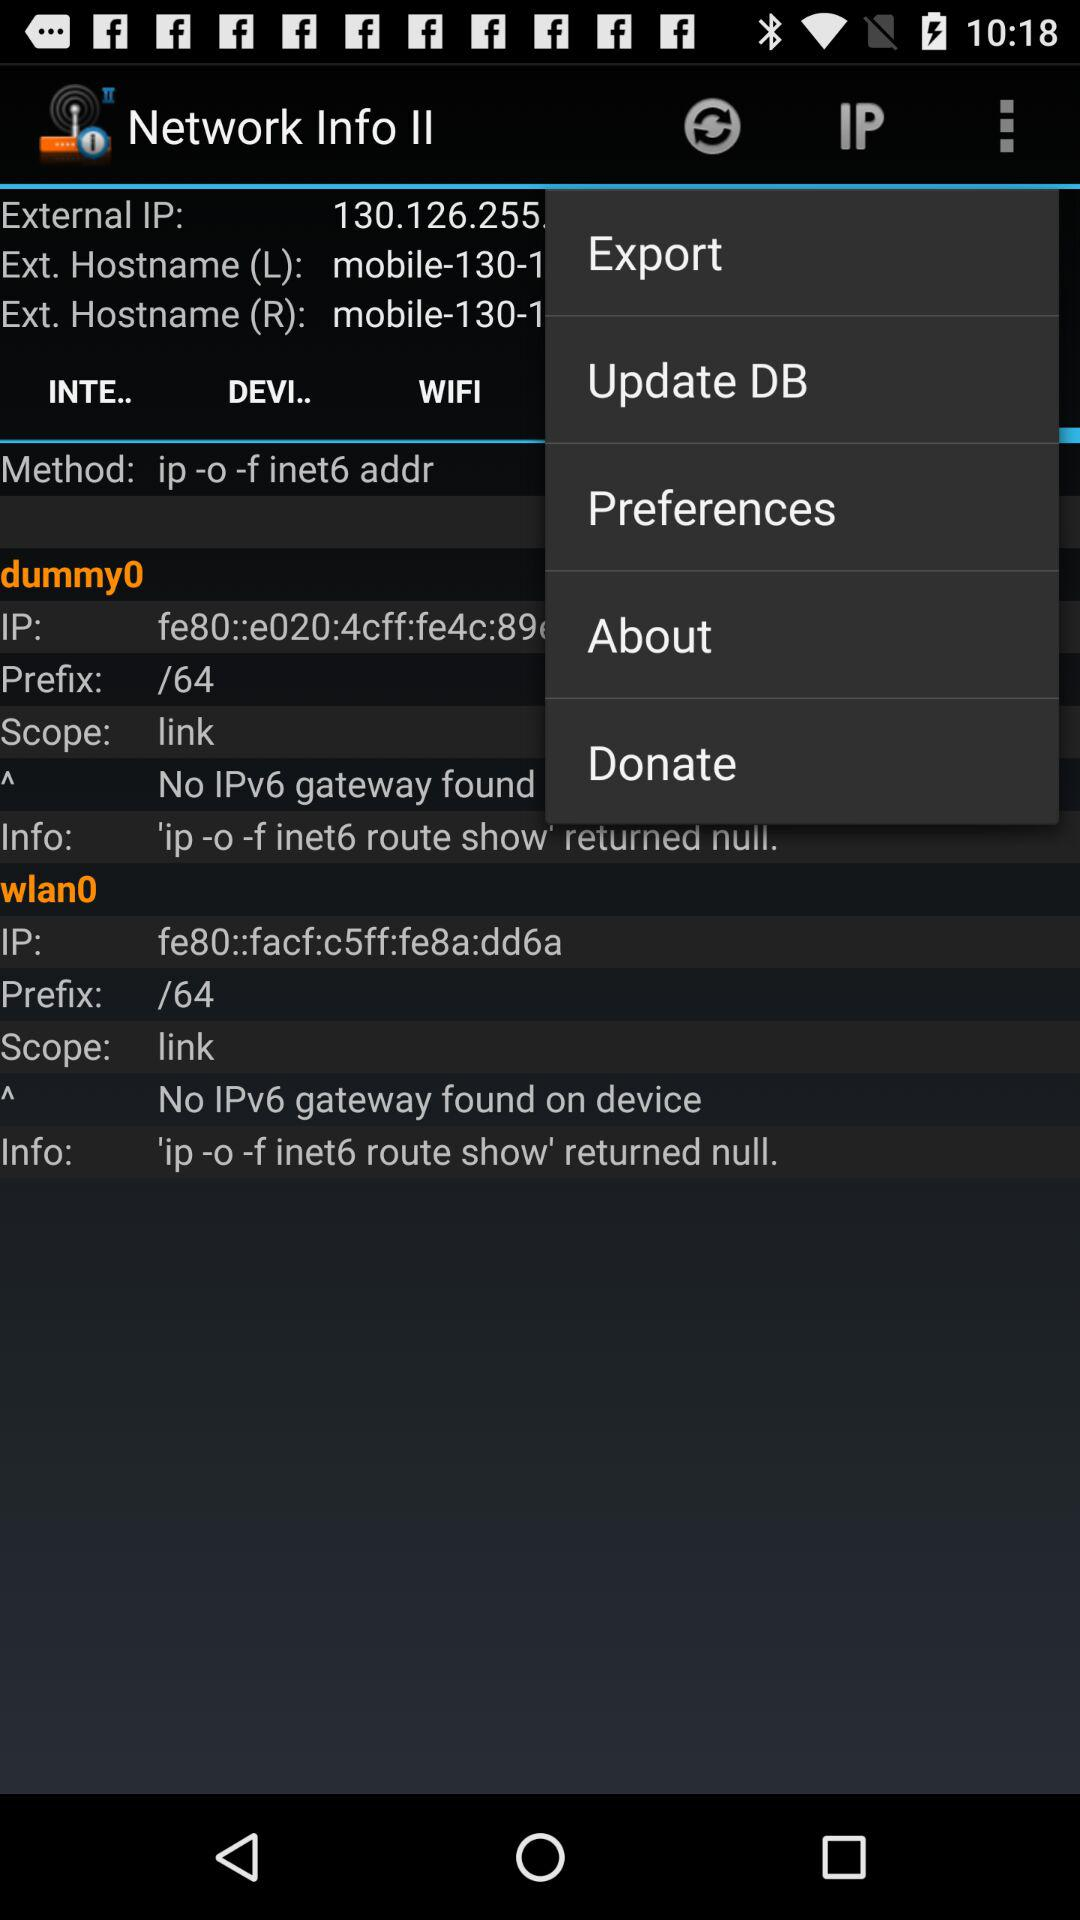How many IPv6 interfaces have a prefix of /64?
Answer the question using a single word or phrase. 2 